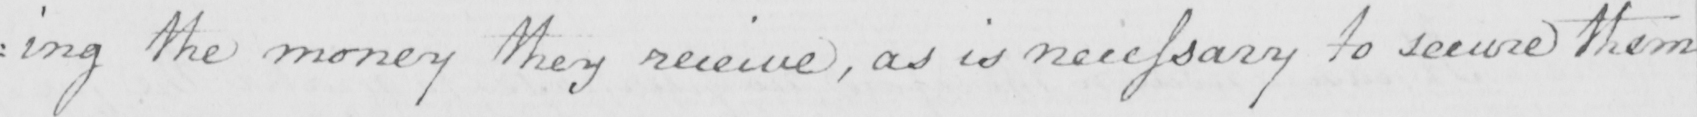Can you read and transcribe this handwriting? : ing the money they receive , as is necessary to secure them 